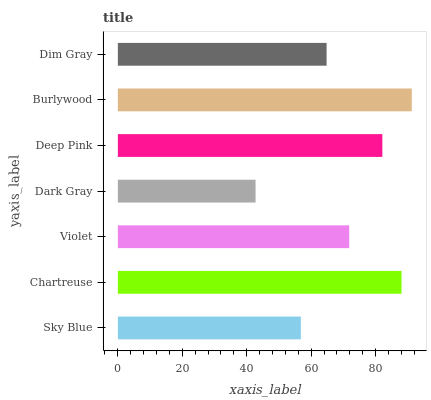Is Dark Gray the minimum?
Answer yes or no. Yes. Is Burlywood the maximum?
Answer yes or no. Yes. Is Chartreuse the minimum?
Answer yes or no. No. Is Chartreuse the maximum?
Answer yes or no. No. Is Chartreuse greater than Sky Blue?
Answer yes or no. Yes. Is Sky Blue less than Chartreuse?
Answer yes or no. Yes. Is Sky Blue greater than Chartreuse?
Answer yes or no. No. Is Chartreuse less than Sky Blue?
Answer yes or no. No. Is Violet the high median?
Answer yes or no. Yes. Is Violet the low median?
Answer yes or no. Yes. Is Burlywood the high median?
Answer yes or no. No. Is Dim Gray the low median?
Answer yes or no. No. 